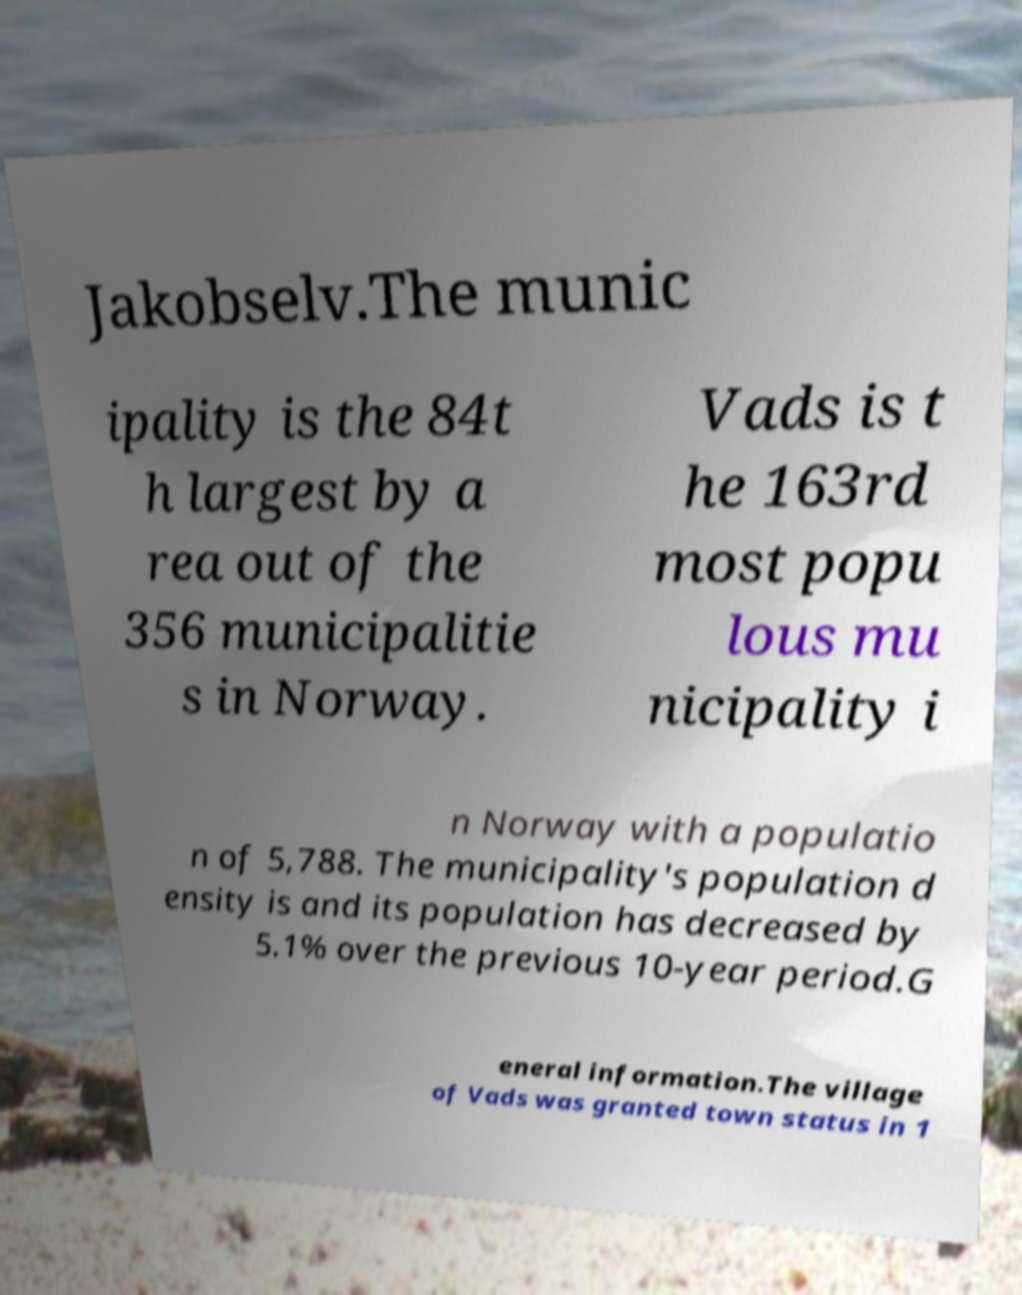Could you assist in decoding the text presented in this image and type it out clearly? Jakobselv.The munic ipality is the 84t h largest by a rea out of the 356 municipalitie s in Norway. Vads is t he 163rd most popu lous mu nicipality i n Norway with a populatio n of 5,788. The municipality's population d ensity is and its population has decreased by 5.1% over the previous 10-year period.G eneral information.The village of Vads was granted town status in 1 